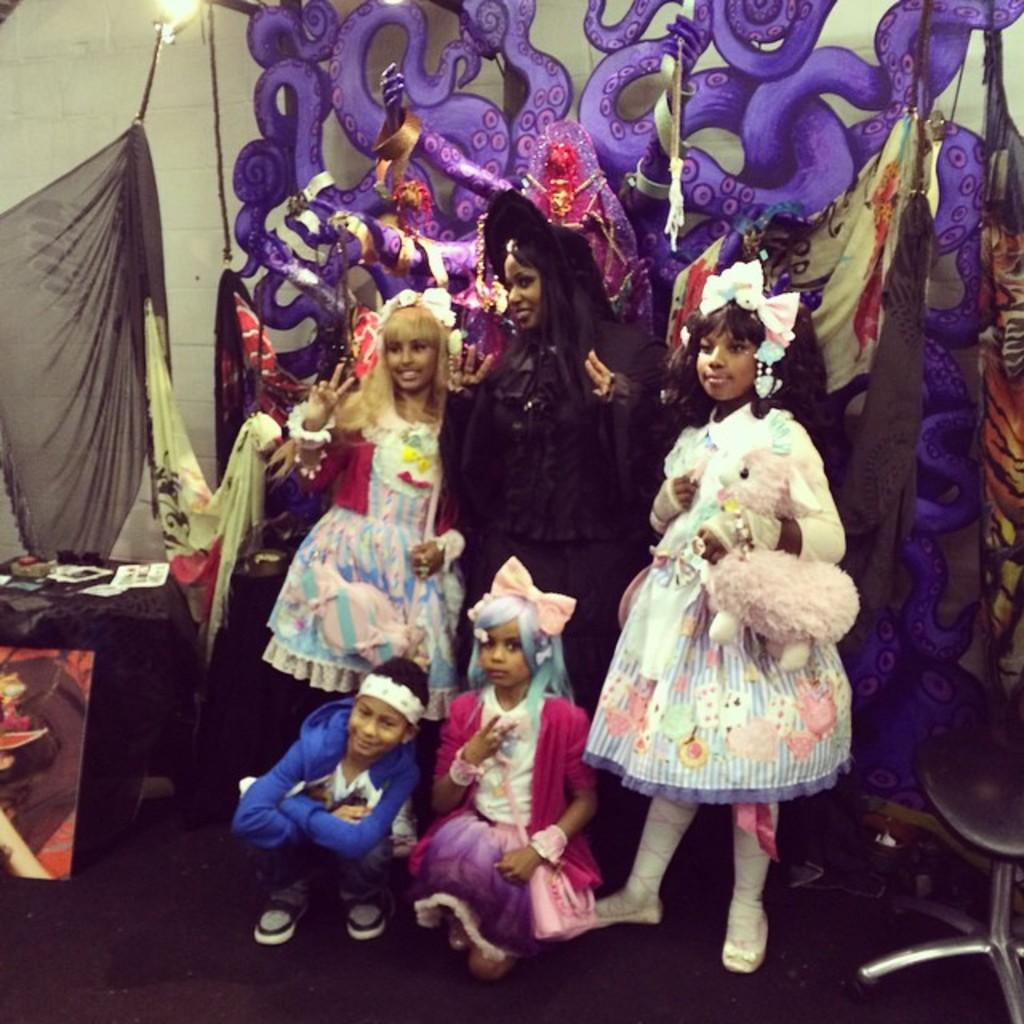What are the people in the image doing? The people in the image are standing and sitting on the floor. What are the people wearing in the image? The people are wearing costumes. What can be seen in the background of the image? There is a table and decorations in the background of the image. What type of grass is growing on the table in the image? There is no grass present in the image; it is a table with decorations in the background. 